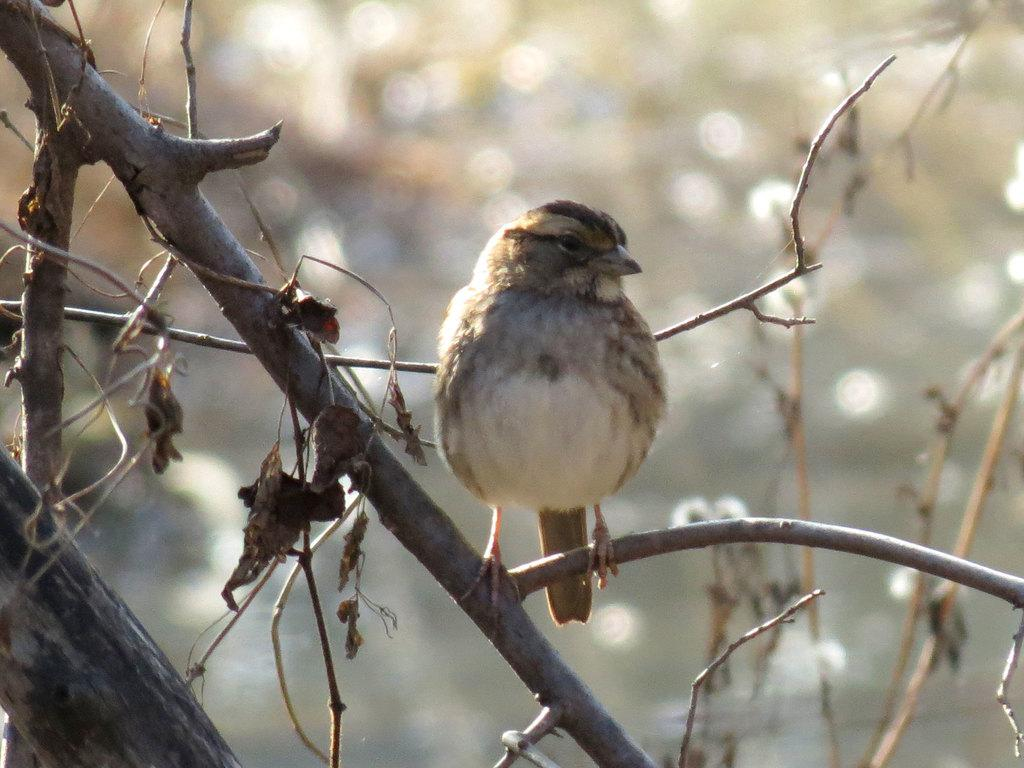What type of animal can be seen in the image? There is a bird in the image. Where is the bird located in the image? The bird is standing on a branch. What is the branch a part of? The branch is part of a tree. Reasoning: Let's think step by step by step in order to produce the conversation. We start by identifying the main subject in the image, which is the bird. Then, we describe the bird's location and the context in which it is found, which is standing on a branch that is part of a tree. Each question is designed to elicit a specific detail about the image that is known from the provided facts. Absurd Question/Answer: What type of tent can be seen in the image? There is no tent present in the image; it features a bird standing on a branch of a tree. 